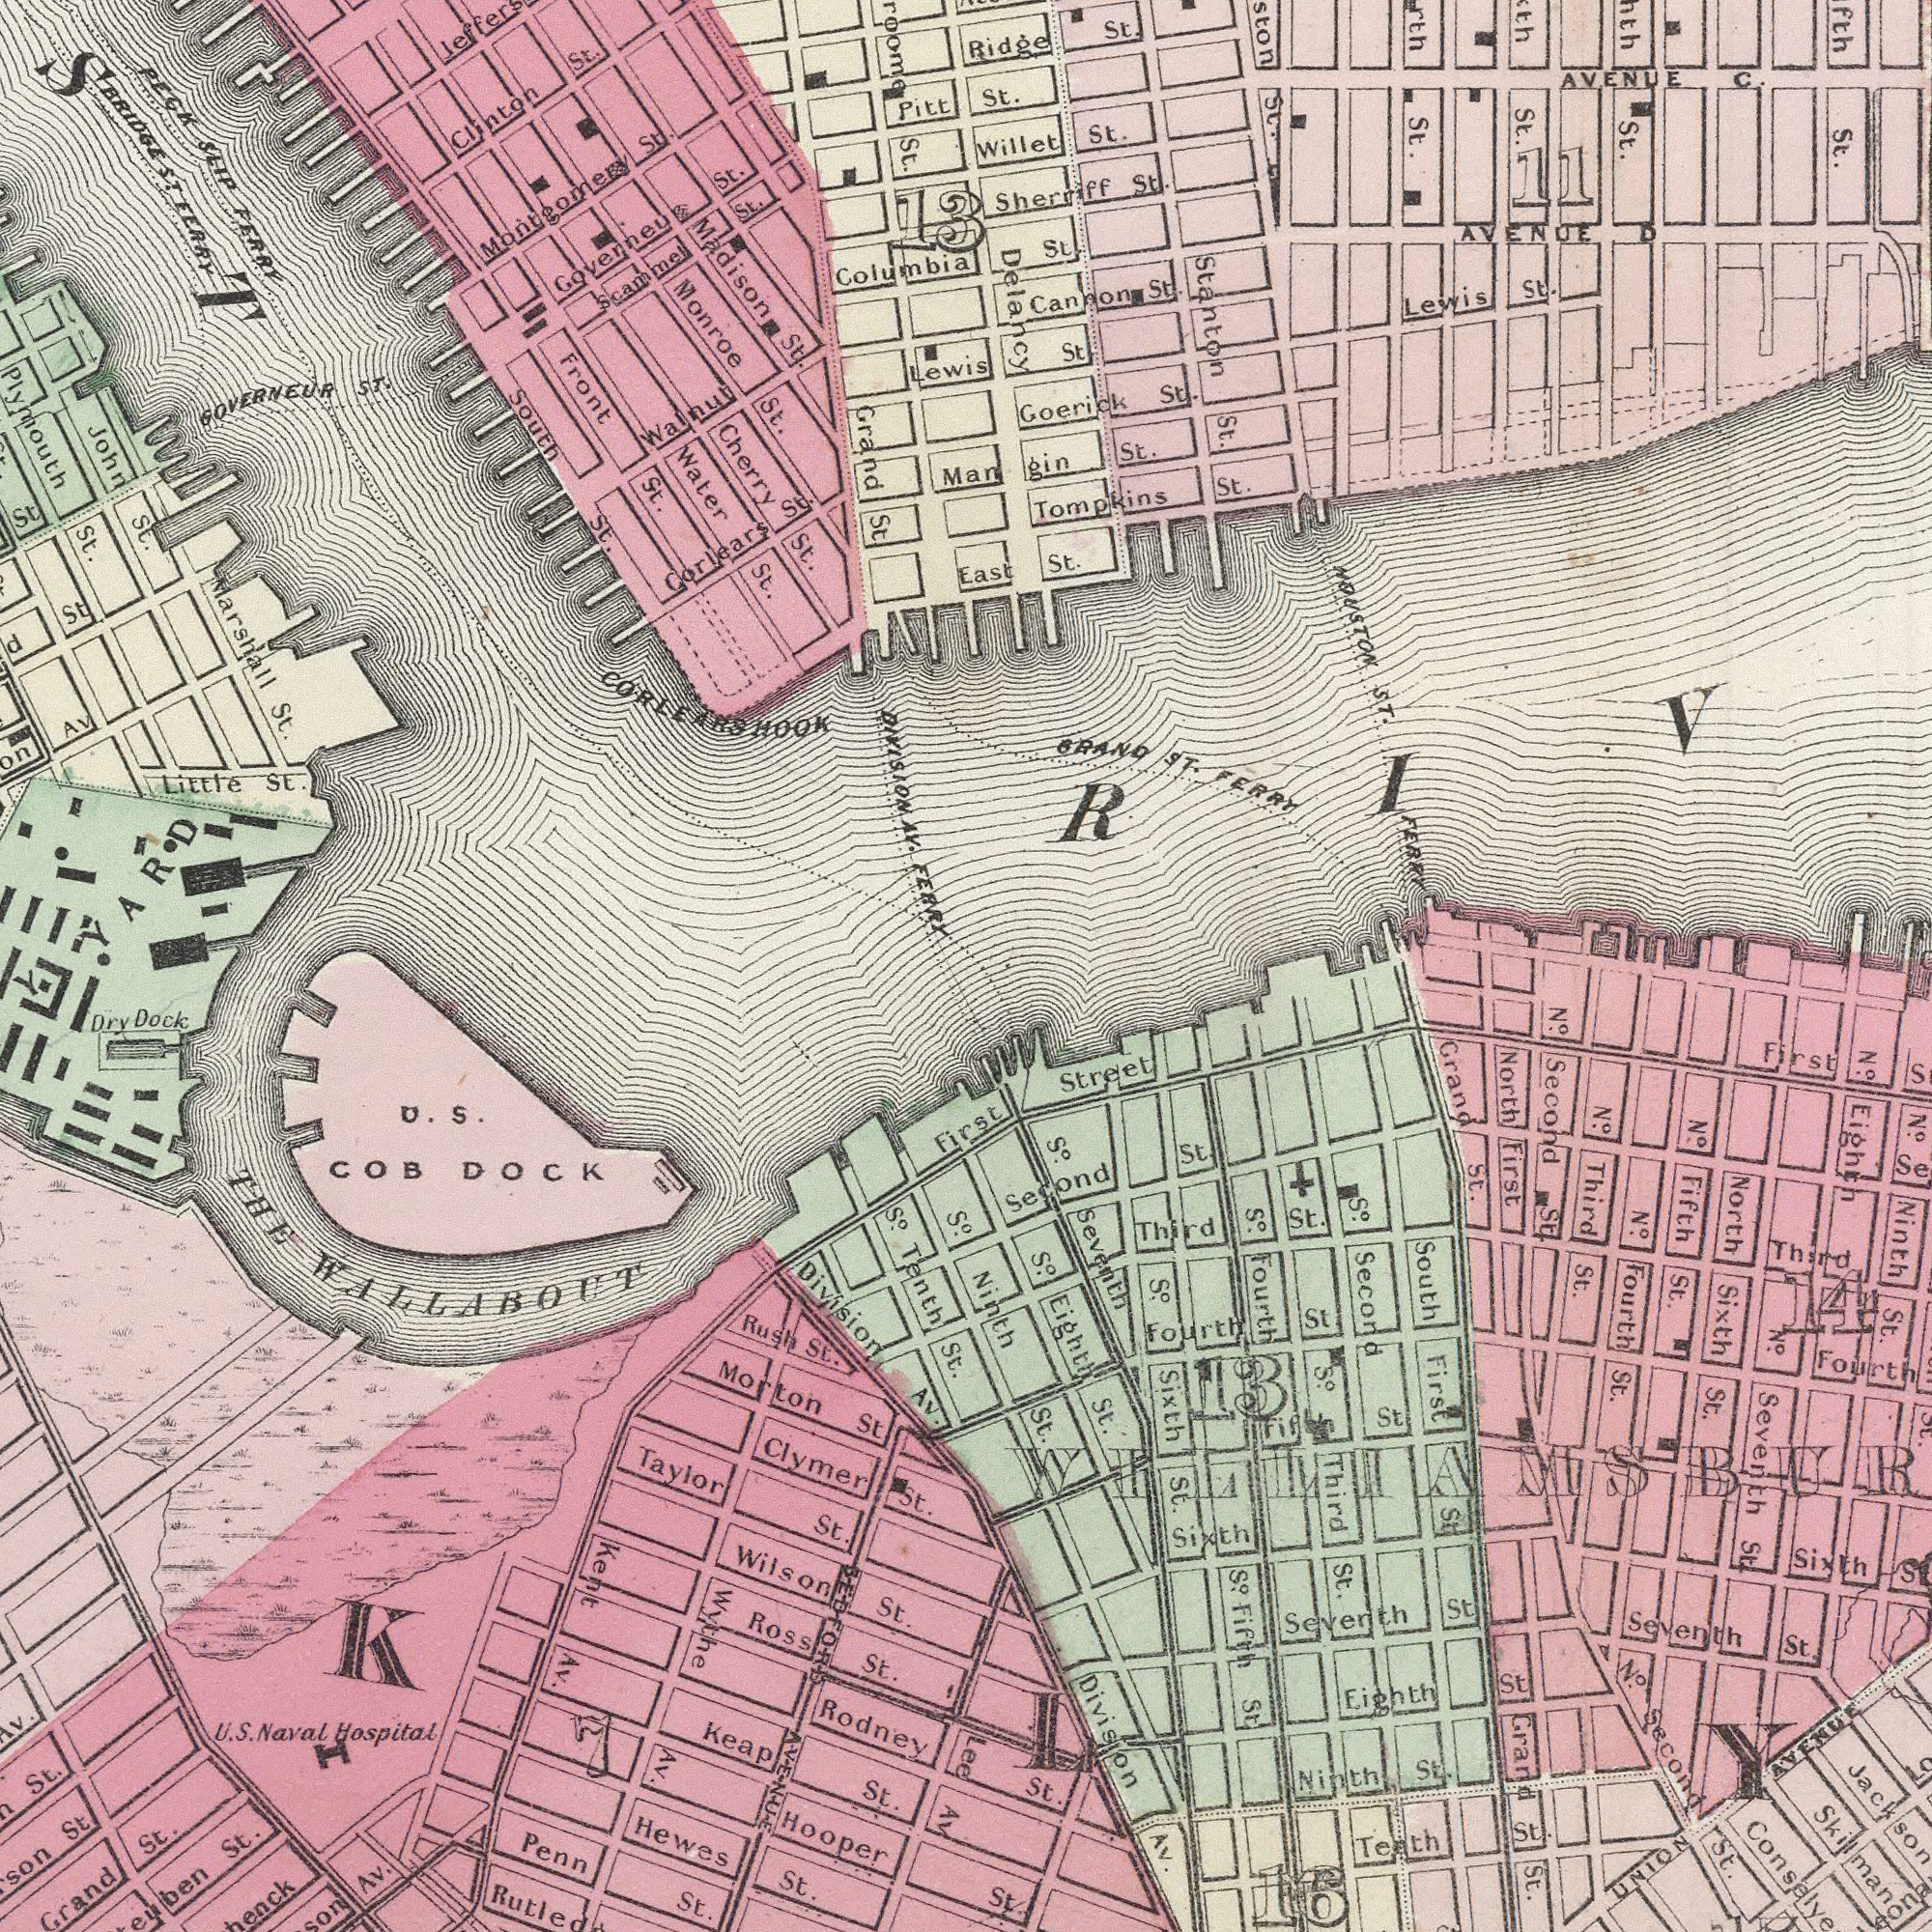What text is visible in the lower-right corner? St. St. Ninth St. Division AV. North First Grand St. South First St Tenth St. S.o Fourth Seventh St N.o Second St S.o Eighth St. N.o Fourth St. North Sixth St. So. Seventh Grand St. N.o Second St. Second St. Sixth First S.o Sixth St. Third St. Third St. S.o Fifth St. Seventh St. N.o Fifth St. Ninth St. Fourth St Eighth St Street Sixth UNION AVENUE Skilman S.o Second N.o Third St. N.o Ninth St. St. S.o Jackson N.o Eighth N.o Seventh St Third First Fourth Lee 16 13 14 What text is shown in the top-right quadrant? St. FERRY St Man gin St. St. St. BRAND ST. FERRY Goerick St. St. Tompkins St. Canoon St. Willet St. Sherriff St. St. St. HOUSTON ST. East St. St. Ridge St. Lewis St. Stanton St. AVENUE C. AVENUE D Delahcy 11 What text is visible in the lower-left corner? Hooper Division AV. Rodney Hewes St. U. S. Naval Hospitat S.o Tenth St. Dry Dock Penn St. Grand St. St. U. S. COB DOCK St. Taylor St. Av. Keap St. Wilson St. Clymer St. Kent Av. Ross St. Rush St. St. Wythe Av. Morton St THE WALLABOUT S.o H Av. 7 BEDFORD AVENUE What text is shown in the top-left quadrant? GOVERNEUR ST. Monroe St. DIVISION AV. FERRY Front St. PECK SLIP FERRY Grand St. Cherry St. Water St. Corlears St. South St. Columbia Plymouth St. Marshall St. Little St. Madison St. Governeu St. John St. Scammel St. St. BRIDGE ST FERRY d st Clinton St. Walnut St. Lewis AV Montgomery St. ###ST Pitt 13 CORLEARS HOOK 